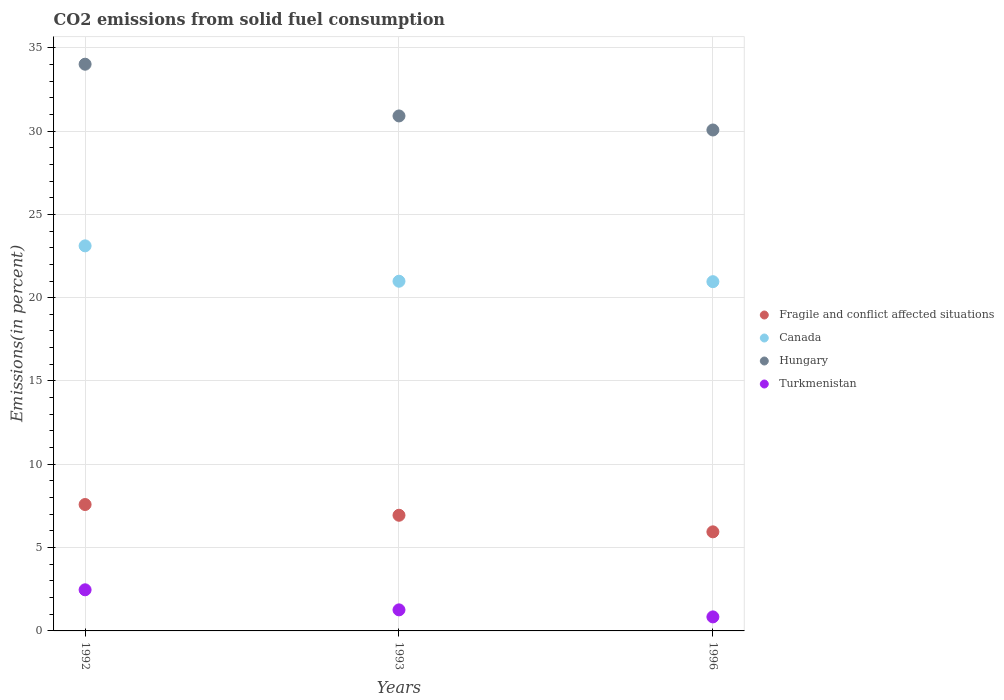What is the total CO2 emitted in Canada in 1993?
Your response must be concise. 20.99. Across all years, what is the maximum total CO2 emitted in Canada?
Make the answer very short. 23.11. Across all years, what is the minimum total CO2 emitted in Turkmenistan?
Provide a short and direct response. 0.84. In which year was the total CO2 emitted in Canada minimum?
Ensure brevity in your answer.  1996. What is the total total CO2 emitted in Hungary in the graph?
Ensure brevity in your answer.  94.98. What is the difference between the total CO2 emitted in Canada in 1993 and that in 1996?
Your response must be concise. 0.03. What is the difference between the total CO2 emitted in Hungary in 1993 and the total CO2 emitted in Fragile and conflict affected situations in 1996?
Ensure brevity in your answer.  24.96. What is the average total CO2 emitted in Turkmenistan per year?
Ensure brevity in your answer.  1.52. In the year 1993, what is the difference between the total CO2 emitted in Turkmenistan and total CO2 emitted in Fragile and conflict affected situations?
Make the answer very short. -5.68. In how many years, is the total CO2 emitted in Canada greater than 11 %?
Offer a very short reply. 3. What is the ratio of the total CO2 emitted in Fragile and conflict affected situations in 1992 to that in 1993?
Your response must be concise. 1.09. Is the total CO2 emitted in Turkmenistan in 1993 less than that in 1996?
Provide a short and direct response. No. What is the difference between the highest and the second highest total CO2 emitted in Hungary?
Offer a very short reply. 3.1. What is the difference between the highest and the lowest total CO2 emitted in Fragile and conflict affected situations?
Give a very brief answer. 1.64. In how many years, is the total CO2 emitted in Canada greater than the average total CO2 emitted in Canada taken over all years?
Your response must be concise. 1. Is it the case that in every year, the sum of the total CO2 emitted in Turkmenistan and total CO2 emitted in Hungary  is greater than the total CO2 emitted in Fragile and conflict affected situations?
Your answer should be compact. Yes. Is the total CO2 emitted in Turkmenistan strictly less than the total CO2 emitted in Fragile and conflict affected situations over the years?
Your answer should be very brief. Yes. How many years are there in the graph?
Ensure brevity in your answer.  3. Does the graph contain any zero values?
Ensure brevity in your answer.  No. How are the legend labels stacked?
Provide a succinct answer. Vertical. What is the title of the graph?
Give a very brief answer. CO2 emissions from solid fuel consumption. Does "Sub-Saharan Africa (all income levels)" appear as one of the legend labels in the graph?
Provide a succinct answer. No. What is the label or title of the X-axis?
Your response must be concise. Years. What is the label or title of the Y-axis?
Give a very brief answer. Emissions(in percent). What is the Emissions(in percent) in Fragile and conflict affected situations in 1992?
Offer a terse response. 7.59. What is the Emissions(in percent) of Canada in 1992?
Offer a very short reply. 23.11. What is the Emissions(in percent) of Hungary in 1992?
Your answer should be compact. 34.01. What is the Emissions(in percent) of Turkmenistan in 1992?
Your answer should be compact. 2.47. What is the Emissions(in percent) of Fragile and conflict affected situations in 1993?
Ensure brevity in your answer.  6.94. What is the Emissions(in percent) in Canada in 1993?
Make the answer very short. 20.99. What is the Emissions(in percent) of Hungary in 1993?
Give a very brief answer. 30.91. What is the Emissions(in percent) of Turkmenistan in 1993?
Provide a succinct answer. 1.26. What is the Emissions(in percent) of Fragile and conflict affected situations in 1996?
Keep it short and to the point. 5.95. What is the Emissions(in percent) in Canada in 1996?
Keep it short and to the point. 20.96. What is the Emissions(in percent) of Hungary in 1996?
Your response must be concise. 30.06. What is the Emissions(in percent) in Turkmenistan in 1996?
Ensure brevity in your answer.  0.84. Across all years, what is the maximum Emissions(in percent) of Fragile and conflict affected situations?
Your answer should be compact. 7.59. Across all years, what is the maximum Emissions(in percent) in Canada?
Make the answer very short. 23.11. Across all years, what is the maximum Emissions(in percent) of Hungary?
Provide a succinct answer. 34.01. Across all years, what is the maximum Emissions(in percent) of Turkmenistan?
Provide a succinct answer. 2.47. Across all years, what is the minimum Emissions(in percent) of Fragile and conflict affected situations?
Provide a short and direct response. 5.95. Across all years, what is the minimum Emissions(in percent) in Canada?
Offer a very short reply. 20.96. Across all years, what is the minimum Emissions(in percent) of Hungary?
Your answer should be compact. 30.06. Across all years, what is the minimum Emissions(in percent) of Turkmenistan?
Offer a terse response. 0.84. What is the total Emissions(in percent) of Fragile and conflict affected situations in the graph?
Your response must be concise. 20.47. What is the total Emissions(in percent) in Canada in the graph?
Ensure brevity in your answer.  65.06. What is the total Emissions(in percent) in Hungary in the graph?
Offer a very short reply. 94.98. What is the total Emissions(in percent) of Turkmenistan in the graph?
Offer a very short reply. 4.57. What is the difference between the Emissions(in percent) in Fragile and conflict affected situations in 1992 and that in 1993?
Your answer should be very brief. 0.64. What is the difference between the Emissions(in percent) in Canada in 1992 and that in 1993?
Your answer should be compact. 2.12. What is the difference between the Emissions(in percent) in Hungary in 1992 and that in 1993?
Offer a terse response. 3.1. What is the difference between the Emissions(in percent) in Turkmenistan in 1992 and that in 1993?
Provide a short and direct response. 1.2. What is the difference between the Emissions(in percent) of Fragile and conflict affected situations in 1992 and that in 1996?
Make the answer very short. 1.64. What is the difference between the Emissions(in percent) in Canada in 1992 and that in 1996?
Make the answer very short. 2.15. What is the difference between the Emissions(in percent) in Hungary in 1992 and that in 1996?
Provide a short and direct response. 3.95. What is the difference between the Emissions(in percent) of Turkmenistan in 1992 and that in 1996?
Make the answer very short. 1.63. What is the difference between the Emissions(in percent) in Canada in 1993 and that in 1996?
Give a very brief answer. 0.03. What is the difference between the Emissions(in percent) in Hungary in 1993 and that in 1996?
Offer a very short reply. 0.84. What is the difference between the Emissions(in percent) in Turkmenistan in 1993 and that in 1996?
Offer a terse response. 0.42. What is the difference between the Emissions(in percent) in Fragile and conflict affected situations in 1992 and the Emissions(in percent) in Canada in 1993?
Make the answer very short. -13.4. What is the difference between the Emissions(in percent) of Fragile and conflict affected situations in 1992 and the Emissions(in percent) of Hungary in 1993?
Offer a very short reply. -23.32. What is the difference between the Emissions(in percent) in Fragile and conflict affected situations in 1992 and the Emissions(in percent) in Turkmenistan in 1993?
Keep it short and to the point. 6.32. What is the difference between the Emissions(in percent) in Canada in 1992 and the Emissions(in percent) in Hungary in 1993?
Provide a succinct answer. -7.8. What is the difference between the Emissions(in percent) in Canada in 1992 and the Emissions(in percent) in Turkmenistan in 1993?
Keep it short and to the point. 21.85. What is the difference between the Emissions(in percent) of Hungary in 1992 and the Emissions(in percent) of Turkmenistan in 1993?
Your answer should be very brief. 32.75. What is the difference between the Emissions(in percent) of Fragile and conflict affected situations in 1992 and the Emissions(in percent) of Canada in 1996?
Provide a succinct answer. -13.37. What is the difference between the Emissions(in percent) of Fragile and conflict affected situations in 1992 and the Emissions(in percent) of Hungary in 1996?
Your answer should be very brief. -22.48. What is the difference between the Emissions(in percent) in Fragile and conflict affected situations in 1992 and the Emissions(in percent) in Turkmenistan in 1996?
Your answer should be compact. 6.74. What is the difference between the Emissions(in percent) of Canada in 1992 and the Emissions(in percent) of Hungary in 1996?
Make the answer very short. -6.95. What is the difference between the Emissions(in percent) in Canada in 1992 and the Emissions(in percent) in Turkmenistan in 1996?
Ensure brevity in your answer.  22.27. What is the difference between the Emissions(in percent) of Hungary in 1992 and the Emissions(in percent) of Turkmenistan in 1996?
Your answer should be very brief. 33.17. What is the difference between the Emissions(in percent) in Fragile and conflict affected situations in 1993 and the Emissions(in percent) in Canada in 1996?
Your response must be concise. -14.02. What is the difference between the Emissions(in percent) of Fragile and conflict affected situations in 1993 and the Emissions(in percent) of Hungary in 1996?
Your answer should be compact. -23.12. What is the difference between the Emissions(in percent) of Fragile and conflict affected situations in 1993 and the Emissions(in percent) of Turkmenistan in 1996?
Your answer should be compact. 6.1. What is the difference between the Emissions(in percent) in Canada in 1993 and the Emissions(in percent) in Hungary in 1996?
Your answer should be very brief. -9.08. What is the difference between the Emissions(in percent) of Canada in 1993 and the Emissions(in percent) of Turkmenistan in 1996?
Ensure brevity in your answer.  20.14. What is the difference between the Emissions(in percent) in Hungary in 1993 and the Emissions(in percent) in Turkmenistan in 1996?
Provide a succinct answer. 30.07. What is the average Emissions(in percent) in Fragile and conflict affected situations per year?
Your response must be concise. 6.82. What is the average Emissions(in percent) in Canada per year?
Offer a very short reply. 21.69. What is the average Emissions(in percent) in Hungary per year?
Your answer should be compact. 31.66. What is the average Emissions(in percent) of Turkmenistan per year?
Ensure brevity in your answer.  1.52. In the year 1992, what is the difference between the Emissions(in percent) of Fragile and conflict affected situations and Emissions(in percent) of Canada?
Keep it short and to the point. -15.52. In the year 1992, what is the difference between the Emissions(in percent) in Fragile and conflict affected situations and Emissions(in percent) in Hungary?
Provide a succinct answer. -26.43. In the year 1992, what is the difference between the Emissions(in percent) of Fragile and conflict affected situations and Emissions(in percent) of Turkmenistan?
Your answer should be very brief. 5.12. In the year 1992, what is the difference between the Emissions(in percent) of Canada and Emissions(in percent) of Hungary?
Ensure brevity in your answer.  -10.9. In the year 1992, what is the difference between the Emissions(in percent) in Canada and Emissions(in percent) in Turkmenistan?
Your answer should be compact. 20.64. In the year 1992, what is the difference between the Emissions(in percent) of Hungary and Emissions(in percent) of Turkmenistan?
Offer a terse response. 31.54. In the year 1993, what is the difference between the Emissions(in percent) of Fragile and conflict affected situations and Emissions(in percent) of Canada?
Your answer should be very brief. -14.05. In the year 1993, what is the difference between the Emissions(in percent) in Fragile and conflict affected situations and Emissions(in percent) in Hungary?
Offer a terse response. -23.97. In the year 1993, what is the difference between the Emissions(in percent) of Fragile and conflict affected situations and Emissions(in percent) of Turkmenistan?
Offer a very short reply. 5.68. In the year 1993, what is the difference between the Emissions(in percent) in Canada and Emissions(in percent) in Hungary?
Ensure brevity in your answer.  -9.92. In the year 1993, what is the difference between the Emissions(in percent) in Canada and Emissions(in percent) in Turkmenistan?
Your answer should be very brief. 19.72. In the year 1993, what is the difference between the Emissions(in percent) of Hungary and Emissions(in percent) of Turkmenistan?
Provide a succinct answer. 29.64. In the year 1996, what is the difference between the Emissions(in percent) in Fragile and conflict affected situations and Emissions(in percent) in Canada?
Your response must be concise. -15.01. In the year 1996, what is the difference between the Emissions(in percent) in Fragile and conflict affected situations and Emissions(in percent) in Hungary?
Your answer should be very brief. -24.12. In the year 1996, what is the difference between the Emissions(in percent) in Fragile and conflict affected situations and Emissions(in percent) in Turkmenistan?
Offer a terse response. 5.1. In the year 1996, what is the difference between the Emissions(in percent) of Canada and Emissions(in percent) of Hungary?
Ensure brevity in your answer.  -9.1. In the year 1996, what is the difference between the Emissions(in percent) of Canada and Emissions(in percent) of Turkmenistan?
Your answer should be very brief. 20.12. In the year 1996, what is the difference between the Emissions(in percent) in Hungary and Emissions(in percent) in Turkmenistan?
Provide a succinct answer. 29.22. What is the ratio of the Emissions(in percent) of Fragile and conflict affected situations in 1992 to that in 1993?
Your response must be concise. 1.09. What is the ratio of the Emissions(in percent) in Canada in 1992 to that in 1993?
Provide a short and direct response. 1.1. What is the ratio of the Emissions(in percent) of Hungary in 1992 to that in 1993?
Your response must be concise. 1.1. What is the ratio of the Emissions(in percent) in Turkmenistan in 1992 to that in 1993?
Give a very brief answer. 1.95. What is the ratio of the Emissions(in percent) in Fragile and conflict affected situations in 1992 to that in 1996?
Offer a very short reply. 1.28. What is the ratio of the Emissions(in percent) of Canada in 1992 to that in 1996?
Provide a short and direct response. 1.1. What is the ratio of the Emissions(in percent) of Hungary in 1992 to that in 1996?
Your response must be concise. 1.13. What is the ratio of the Emissions(in percent) of Turkmenistan in 1992 to that in 1996?
Your answer should be very brief. 2.93. What is the ratio of the Emissions(in percent) of Fragile and conflict affected situations in 1993 to that in 1996?
Make the answer very short. 1.17. What is the ratio of the Emissions(in percent) in Canada in 1993 to that in 1996?
Offer a very short reply. 1. What is the ratio of the Emissions(in percent) of Hungary in 1993 to that in 1996?
Offer a very short reply. 1.03. What is the ratio of the Emissions(in percent) of Turkmenistan in 1993 to that in 1996?
Make the answer very short. 1.5. What is the difference between the highest and the second highest Emissions(in percent) of Fragile and conflict affected situations?
Keep it short and to the point. 0.64. What is the difference between the highest and the second highest Emissions(in percent) in Canada?
Offer a terse response. 2.12. What is the difference between the highest and the second highest Emissions(in percent) in Hungary?
Provide a short and direct response. 3.1. What is the difference between the highest and the second highest Emissions(in percent) in Turkmenistan?
Keep it short and to the point. 1.2. What is the difference between the highest and the lowest Emissions(in percent) of Fragile and conflict affected situations?
Your response must be concise. 1.64. What is the difference between the highest and the lowest Emissions(in percent) of Canada?
Provide a short and direct response. 2.15. What is the difference between the highest and the lowest Emissions(in percent) of Hungary?
Provide a short and direct response. 3.95. What is the difference between the highest and the lowest Emissions(in percent) in Turkmenistan?
Offer a very short reply. 1.63. 